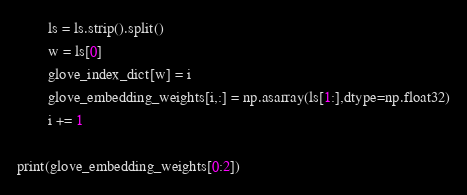<code> <loc_0><loc_0><loc_500><loc_500><_Python_>        ls = ls.strip().split()
        w = ls[0]
        glove_index_dict[w] = i
        glove_embedding_weights[i,:] = np.asarray(ls[1:],dtype=np.float32)
        i += 1

print(glove_embedding_weights[0:2])


</code> 